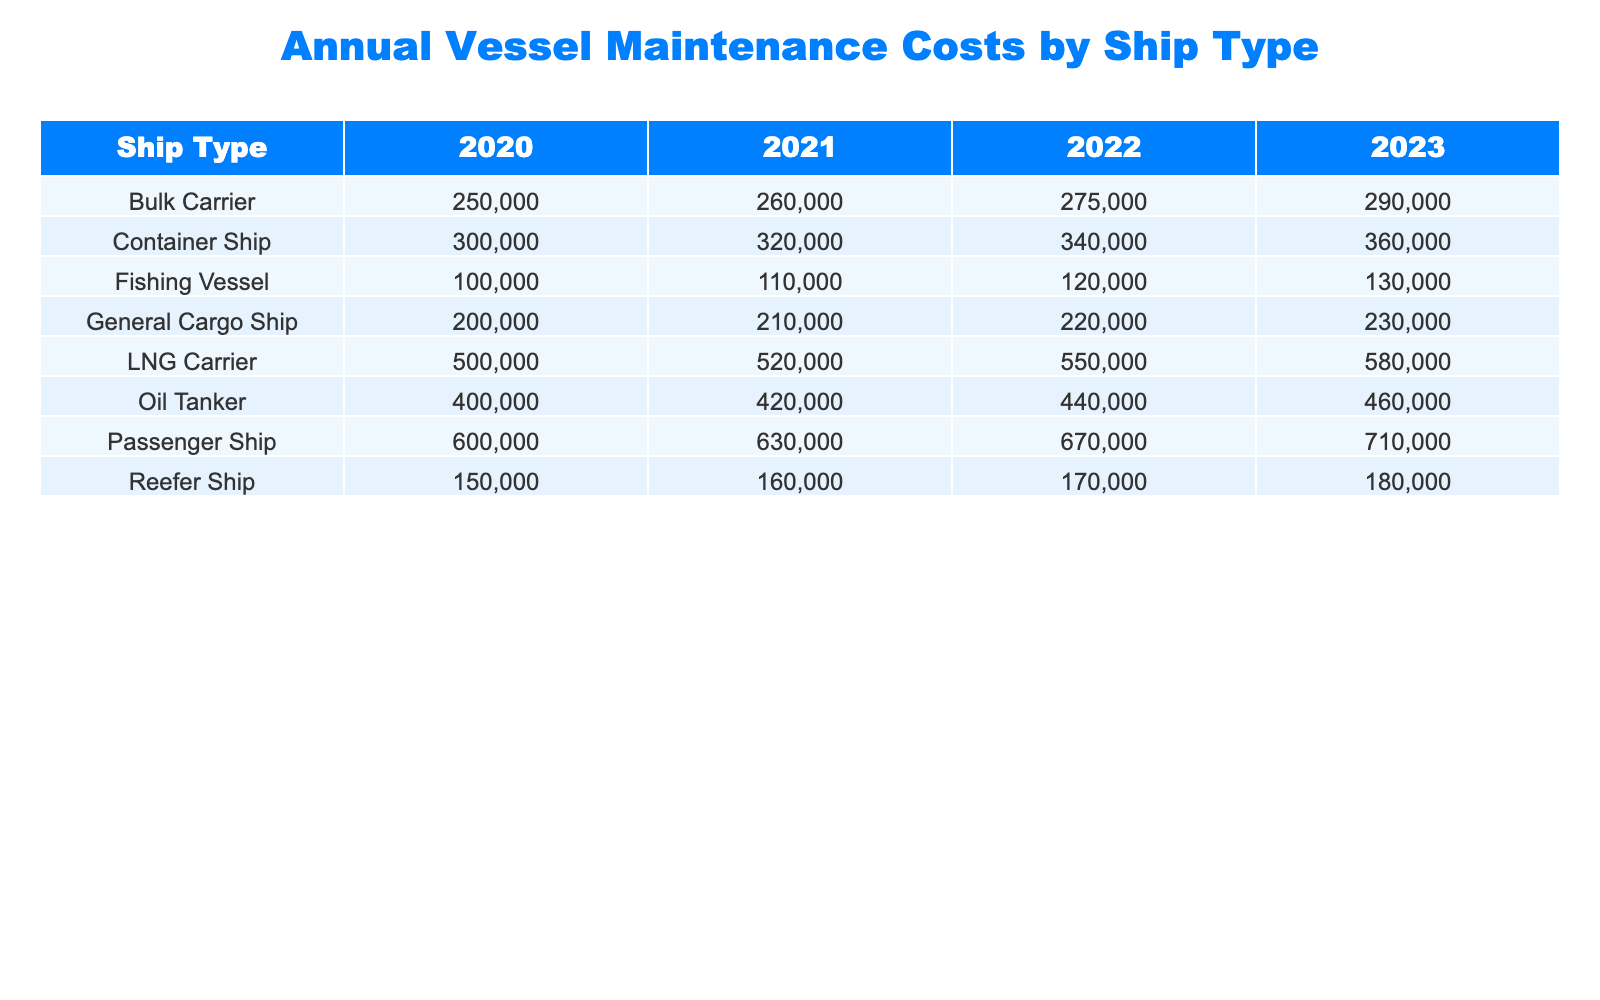What is the maintenance cost for Oil Tankers in 2022? According to the table, the maintenance cost for Oil Tankers in 2022 is directly listed as 440000 USD.
Answer: 440000 USD What is the maximum maintenance cost recorded for any ship type in 2023? By reviewing the costs listed for each ship type in 2023, the highest maintenance cost is for the Passenger Ship at 710000 USD.
Answer: 710000 USD How much did the maintenance cost for Container Ships increase from 2021 to 2023? The maintenance cost for Container Ships in 2021 was 320000 USD, and in 2023, it rose to 360000 USD. The difference is calculated as 360000 - 320000 = 40000 USD.
Answer: 40000 USD What is the average maintenance cost for Bulk Carriers over the four years? The maintenance costs for Bulk Carriers for the years are 250000, 260000, 275000, and 290000 USD. Summing these values gives 250000 + 260000 + 275000 + 290000 = 1075000 USD. Dividing by 4 gives an average of 1075000 / 4 = 268750 USD.
Answer: 268750 USD Did the maintenance costs for Reefer Ships decrease from 2020 to 2021? The maintenance cost for Reefer Ships in 2020 is 150000 USD, and in 2021, it is 160000 USD, indicating an increase rather than a decrease. Therefore, the statement is false.
Answer: No What is the total maintenance cost for all ship types combined in 2020? To determine the total maintenance cost for all ship types in 2020, add the costs: 300000 + 250000 + 400000 + 500000 + 200000 + 150000 + 100000 + 600000 = 2050000 USD.
Answer: 2050000 USD Which ship type had the highest maintenance cost in 2021, and what was that cost? By looking at the 2021 maintenance cost for each ship type, the Oil Tanker has the highest cost at 420000 USD.
Answer: Oil Tanker, 420000 USD How much more did the maintenance cost for Passenger Ships in 2022 compare to Fishing Vessels in the same year? The maintenance cost for Passenger Ships in 2022 is 670000 USD, while for Fishing Vessels, it is 120000 USD. The difference is 670000 - 120000 = 550000 USD.
Answer: 550000 USD Did all ship types see an increase in maintenance costs from 2020 to 2023? Evaluating each ship type’s costs over these years shows that every ship type experienced an increase in maintenance costs from 2020 to 2023, confirming the statement is true.
Answer: Yes 